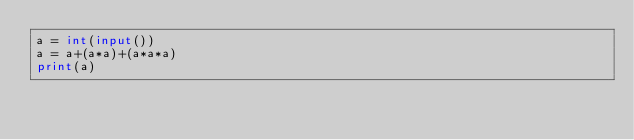<code> <loc_0><loc_0><loc_500><loc_500><_Python_>a = int(input())
a = a+(a*a)+(a*a*a)
print(a)</code> 